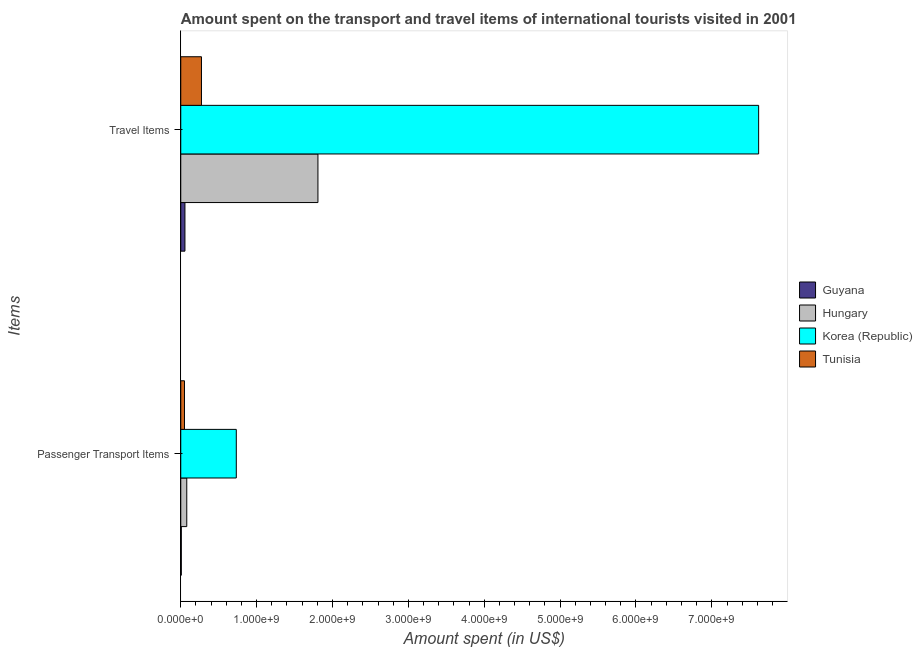How many different coloured bars are there?
Your answer should be compact. 4. How many groups of bars are there?
Offer a very short reply. 2. Are the number of bars per tick equal to the number of legend labels?
Make the answer very short. Yes. How many bars are there on the 2nd tick from the top?
Provide a short and direct response. 4. How many bars are there on the 2nd tick from the bottom?
Your answer should be very brief. 4. What is the label of the 1st group of bars from the top?
Give a very brief answer. Travel Items. What is the amount spent on passenger transport items in Hungary?
Make the answer very short. 7.90e+07. Across all countries, what is the maximum amount spent on passenger transport items?
Make the answer very short. 7.32e+08. Across all countries, what is the minimum amount spent in travel items?
Ensure brevity in your answer.  5.50e+07. In which country was the amount spent in travel items maximum?
Your answer should be compact. Korea (Republic). In which country was the amount spent in travel items minimum?
Your answer should be very brief. Guyana. What is the total amount spent on passenger transport items in the graph?
Offer a terse response. 8.67e+08. What is the difference between the amount spent in travel items in Guyana and that in Hungary?
Keep it short and to the point. -1.75e+09. What is the difference between the amount spent on passenger transport items in Korea (Republic) and the amount spent in travel items in Guyana?
Offer a very short reply. 6.77e+08. What is the average amount spent on passenger transport items per country?
Make the answer very short. 2.17e+08. What is the difference between the amount spent on passenger transport items and amount spent in travel items in Tunisia?
Your answer should be compact. -2.24e+08. In how many countries, is the amount spent on passenger transport items greater than 4800000000 US$?
Make the answer very short. 0. What is the ratio of the amount spent on passenger transport items in Hungary to that in Guyana?
Keep it short and to the point. 11.29. Is the amount spent in travel items in Guyana less than that in Hungary?
Keep it short and to the point. Yes. In how many countries, is the amount spent in travel items greater than the average amount spent in travel items taken over all countries?
Offer a very short reply. 1. What does the 3rd bar from the top in Passenger Transport Items represents?
Give a very brief answer. Hungary. What does the 1st bar from the bottom in Travel Items represents?
Your answer should be compact. Guyana. How many bars are there?
Keep it short and to the point. 8. How many countries are there in the graph?
Your answer should be very brief. 4. Does the graph contain grids?
Provide a short and direct response. No. How are the legend labels stacked?
Provide a succinct answer. Vertical. What is the title of the graph?
Offer a very short reply. Amount spent on the transport and travel items of international tourists visited in 2001. Does "Bhutan" appear as one of the legend labels in the graph?
Your response must be concise. No. What is the label or title of the X-axis?
Your answer should be very brief. Amount spent (in US$). What is the label or title of the Y-axis?
Ensure brevity in your answer.  Items. What is the Amount spent (in US$) of Hungary in Passenger Transport Items?
Your answer should be very brief. 7.90e+07. What is the Amount spent (in US$) in Korea (Republic) in Passenger Transport Items?
Offer a very short reply. 7.32e+08. What is the Amount spent (in US$) of Tunisia in Passenger Transport Items?
Your answer should be compact. 4.90e+07. What is the Amount spent (in US$) in Guyana in Travel Items?
Offer a terse response. 5.50e+07. What is the Amount spent (in US$) of Hungary in Travel Items?
Offer a terse response. 1.81e+09. What is the Amount spent (in US$) in Korea (Republic) in Travel Items?
Provide a short and direct response. 7.62e+09. What is the Amount spent (in US$) in Tunisia in Travel Items?
Provide a short and direct response. 2.73e+08. Across all Items, what is the maximum Amount spent (in US$) in Guyana?
Provide a succinct answer. 5.50e+07. Across all Items, what is the maximum Amount spent (in US$) of Hungary?
Keep it short and to the point. 1.81e+09. Across all Items, what is the maximum Amount spent (in US$) in Korea (Republic)?
Give a very brief answer. 7.62e+09. Across all Items, what is the maximum Amount spent (in US$) in Tunisia?
Provide a succinct answer. 2.73e+08. Across all Items, what is the minimum Amount spent (in US$) in Hungary?
Make the answer very short. 7.90e+07. Across all Items, what is the minimum Amount spent (in US$) of Korea (Republic)?
Ensure brevity in your answer.  7.32e+08. Across all Items, what is the minimum Amount spent (in US$) of Tunisia?
Provide a short and direct response. 4.90e+07. What is the total Amount spent (in US$) of Guyana in the graph?
Ensure brevity in your answer.  6.20e+07. What is the total Amount spent (in US$) of Hungary in the graph?
Make the answer very short. 1.89e+09. What is the total Amount spent (in US$) in Korea (Republic) in the graph?
Ensure brevity in your answer.  8.35e+09. What is the total Amount spent (in US$) of Tunisia in the graph?
Give a very brief answer. 3.22e+08. What is the difference between the Amount spent (in US$) in Guyana in Passenger Transport Items and that in Travel Items?
Your answer should be compact. -4.80e+07. What is the difference between the Amount spent (in US$) of Hungary in Passenger Transport Items and that in Travel Items?
Provide a short and direct response. -1.73e+09. What is the difference between the Amount spent (in US$) of Korea (Republic) in Passenger Transport Items and that in Travel Items?
Your answer should be very brief. -6.88e+09. What is the difference between the Amount spent (in US$) in Tunisia in Passenger Transport Items and that in Travel Items?
Ensure brevity in your answer.  -2.24e+08. What is the difference between the Amount spent (in US$) of Guyana in Passenger Transport Items and the Amount spent (in US$) of Hungary in Travel Items?
Your response must be concise. -1.80e+09. What is the difference between the Amount spent (in US$) in Guyana in Passenger Transport Items and the Amount spent (in US$) in Korea (Republic) in Travel Items?
Your answer should be very brief. -7.61e+09. What is the difference between the Amount spent (in US$) in Guyana in Passenger Transport Items and the Amount spent (in US$) in Tunisia in Travel Items?
Your answer should be very brief. -2.66e+08. What is the difference between the Amount spent (in US$) of Hungary in Passenger Transport Items and the Amount spent (in US$) of Korea (Republic) in Travel Items?
Your answer should be very brief. -7.54e+09. What is the difference between the Amount spent (in US$) of Hungary in Passenger Transport Items and the Amount spent (in US$) of Tunisia in Travel Items?
Offer a very short reply. -1.94e+08. What is the difference between the Amount spent (in US$) in Korea (Republic) in Passenger Transport Items and the Amount spent (in US$) in Tunisia in Travel Items?
Your answer should be very brief. 4.59e+08. What is the average Amount spent (in US$) of Guyana per Items?
Offer a very short reply. 3.10e+07. What is the average Amount spent (in US$) of Hungary per Items?
Provide a succinct answer. 9.44e+08. What is the average Amount spent (in US$) in Korea (Republic) per Items?
Your response must be concise. 4.17e+09. What is the average Amount spent (in US$) in Tunisia per Items?
Offer a terse response. 1.61e+08. What is the difference between the Amount spent (in US$) in Guyana and Amount spent (in US$) in Hungary in Passenger Transport Items?
Provide a short and direct response. -7.20e+07. What is the difference between the Amount spent (in US$) of Guyana and Amount spent (in US$) of Korea (Republic) in Passenger Transport Items?
Make the answer very short. -7.25e+08. What is the difference between the Amount spent (in US$) of Guyana and Amount spent (in US$) of Tunisia in Passenger Transport Items?
Your answer should be compact. -4.20e+07. What is the difference between the Amount spent (in US$) in Hungary and Amount spent (in US$) in Korea (Republic) in Passenger Transport Items?
Your answer should be very brief. -6.53e+08. What is the difference between the Amount spent (in US$) of Hungary and Amount spent (in US$) of Tunisia in Passenger Transport Items?
Make the answer very short. 3.00e+07. What is the difference between the Amount spent (in US$) of Korea (Republic) and Amount spent (in US$) of Tunisia in Passenger Transport Items?
Offer a terse response. 6.83e+08. What is the difference between the Amount spent (in US$) of Guyana and Amount spent (in US$) of Hungary in Travel Items?
Give a very brief answer. -1.75e+09. What is the difference between the Amount spent (in US$) of Guyana and Amount spent (in US$) of Korea (Republic) in Travel Items?
Provide a succinct answer. -7.56e+09. What is the difference between the Amount spent (in US$) in Guyana and Amount spent (in US$) in Tunisia in Travel Items?
Give a very brief answer. -2.18e+08. What is the difference between the Amount spent (in US$) in Hungary and Amount spent (in US$) in Korea (Republic) in Travel Items?
Provide a short and direct response. -5.81e+09. What is the difference between the Amount spent (in US$) of Hungary and Amount spent (in US$) of Tunisia in Travel Items?
Offer a terse response. 1.54e+09. What is the difference between the Amount spent (in US$) of Korea (Republic) and Amount spent (in US$) of Tunisia in Travel Items?
Provide a succinct answer. 7.34e+09. What is the ratio of the Amount spent (in US$) in Guyana in Passenger Transport Items to that in Travel Items?
Your answer should be compact. 0.13. What is the ratio of the Amount spent (in US$) in Hungary in Passenger Transport Items to that in Travel Items?
Offer a very short reply. 0.04. What is the ratio of the Amount spent (in US$) in Korea (Republic) in Passenger Transport Items to that in Travel Items?
Offer a very short reply. 0.1. What is the ratio of the Amount spent (in US$) of Tunisia in Passenger Transport Items to that in Travel Items?
Offer a very short reply. 0.18. What is the difference between the highest and the second highest Amount spent (in US$) of Guyana?
Keep it short and to the point. 4.80e+07. What is the difference between the highest and the second highest Amount spent (in US$) of Hungary?
Ensure brevity in your answer.  1.73e+09. What is the difference between the highest and the second highest Amount spent (in US$) in Korea (Republic)?
Your answer should be compact. 6.88e+09. What is the difference between the highest and the second highest Amount spent (in US$) in Tunisia?
Offer a terse response. 2.24e+08. What is the difference between the highest and the lowest Amount spent (in US$) in Guyana?
Your answer should be compact. 4.80e+07. What is the difference between the highest and the lowest Amount spent (in US$) in Hungary?
Ensure brevity in your answer.  1.73e+09. What is the difference between the highest and the lowest Amount spent (in US$) in Korea (Republic)?
Your response must be concise. 6.88e+09. What is the difference between the highest and the lowest Amount spent (in US$) of Tunisia?
Make the answer very short. 2.24e+08. 